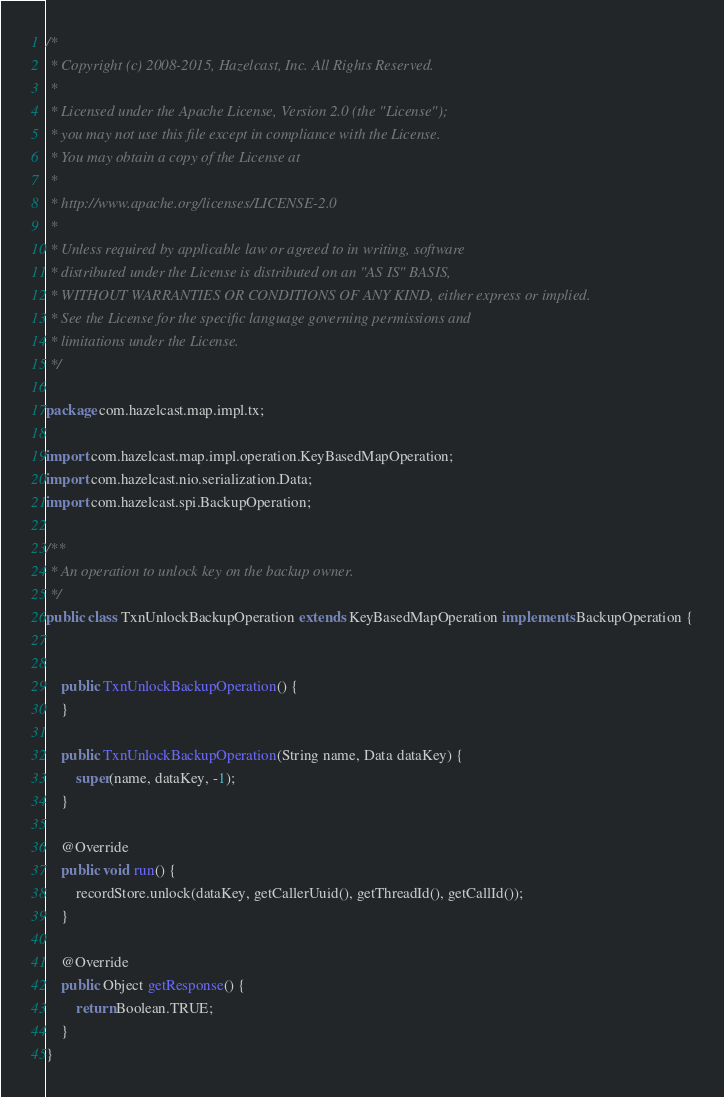Convert code to text. <code><loc_0><loc_0><loc_500><loc_500><_Java_>/*
 * Copyright (c) 2008-2015, Hazelcast, Inc. All Rights Reserved.
 *
 * Licensed under the Apache License, Version 2.0 (the "License");
 * you may not use this file except in compliance with the License.
 * You may obtain a copy of the License at
 *
 * http://www.apache.org/licenses/LICENSE-2.0
 *
 * Unless required by applicable law or agreed to in writing, software
 * distributed under the License is distributed on an "AS IS" BASIS,
 * WITHOUT WARRANTIES OR CONDITIONS OF ANY KIND, either express or implied.
 * See the License for the specific language governing permissions and
 * limitations under the License.
 */

package com.hazelcast.map.impl.tx;

import com.hazelcast.map.impl.operation.KeyBasedMapOperation;
import com.hazelcast.nio.serialization.Data;
import com.hazelcast.spi.BackupOperation;

/**
 * An operation to unlock key on the backup owner.
 */
public class TxnUnlockBackupOperation extends KeyBasedMapOperation implements BackupOperation {


    public TxnUnlockBackupOperation() {
    }

    public TxnUnlockBackupOperation(String name, Data dataKey) {
        super(name, dataKey, -1);
    }

    @Override
    public void run() {
        recordStore.unlock(dataKey, getCallerUuid(), getThreadId(), getCallId());
    }

    @Override
    public Object getResponse() {
        return Boolean.TRUE;
    }
}
</code> 